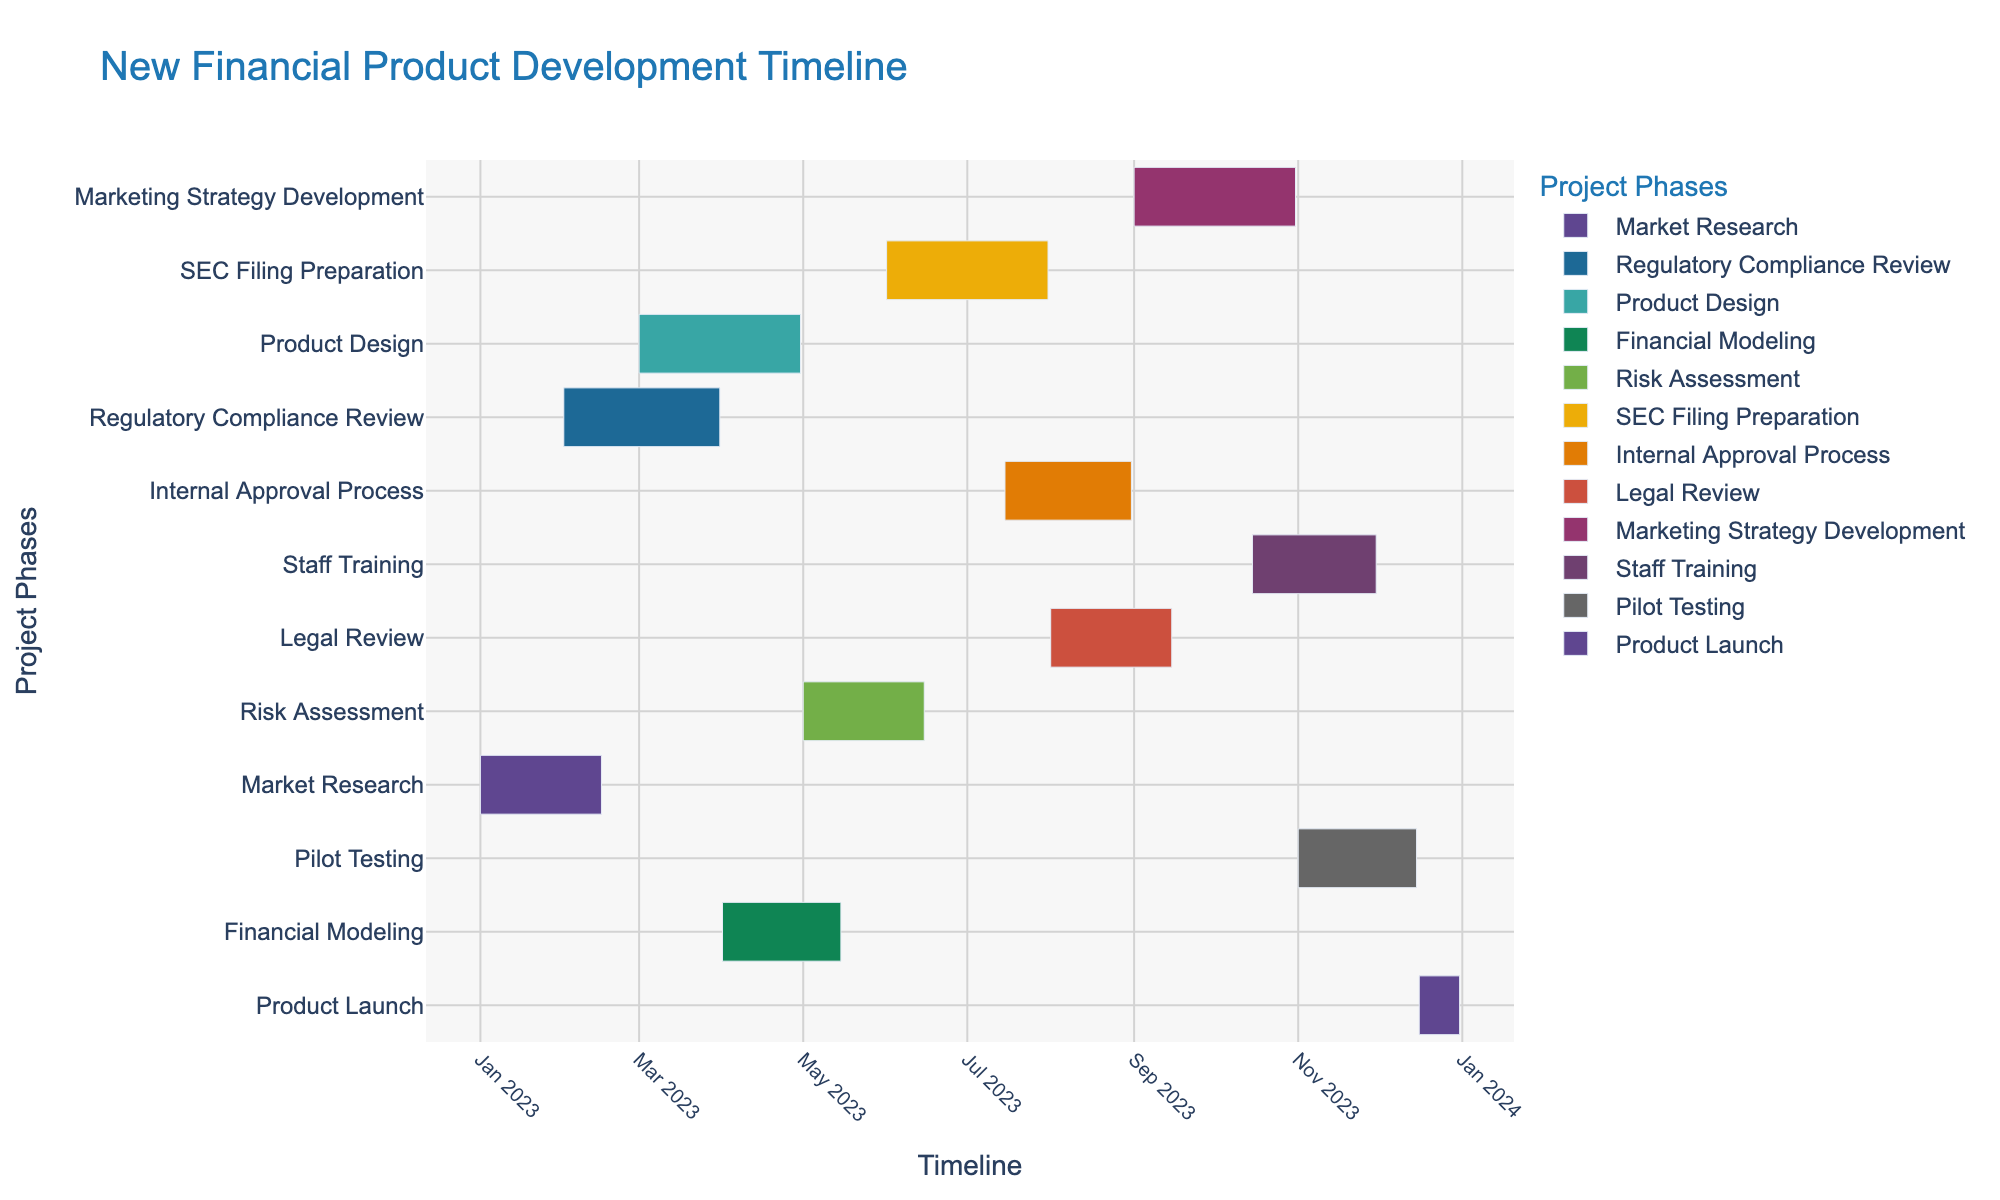What is the total duration of the "Market Research" phase? The "Market Research" phase starts on January 1, 2023, and ends on February 15, 2023. Calculating the duration between these two dates: Duration = February 15, 2023 - January 1, 2023 = 45 days
Answer: 45 days Which project phase overlaps with both "Market Research" and "Product Design"? To determine which phase overlaps with both "Market Research" and "Product Design," we look for a project phase that starts before "Market Research" ends (February 15, 2023) and ends after "Product Design" starts (March 1, 2023). "Regulatory Compliance Review" fits this as it starts on February 1, 2023, and ends on March 31, 2023
Answer: Regulatory Compliance Review When does the "Pilot Testing" phase commence and conclude? The "Pilot Testing" phase begins on November 1, 2023, and ends on December 15, 2023, based on the Gantt chart's provided timeline.
Answer: November 1, 2023, to December 15, 2023 What activities are ongoing in July 2023? To find the activities ongoing in July 2023, examine the phases that overlap with the timeline of July 2023. The phases are "SEC Filing Preparation," "Internal Approval Process," and "Legal Review."
Answer: SEC Filing Preparation, Internal Approval Process, Legal Review What is the shortest project phase in terms of duration? To determine the shortest project phase, compare the durations of each phase. The shortest phase is the "Product Launch" phase, which has a duration of 15 days (December 16, 2023, to December 31, 2023).
Answer: Product Launch How many phases are overlapping with "Staff Training"? "Staff Training" runs from October 15, 2023, to November 30, 2023. Evaluating the timeline on this chart shows that "Marketing Strategy Development" and "Pilot Testing" overlap with "Staff Training."
Answer: Two phases What phase follows immediately after "Internal Approval Process"? The sequence of phases on the Gantt chart shows that "Legal Review" begins immediately after "Internal Approval Process" ends on August 31, 2023, with "Legal Review" starting on September 1, 2023.
Answer: Legal Review How many days will take from the start of "Financial Modeling" to the end of the "Pilot Testing"? "Financial Modeling" starts on April 1, 2023, and "Pilot Testing" ends on December 15, 2023. Calculating the duration: December 15, 2023 - April 1, 2023 = 258 days.
Answer: 258 days What are the starting and ending dates for "Marketing Strategy Development"? Based on the chart, "Marketing Strategy Development" starts on September 1, 2023, and ends on October 31, 2023.
Answer: September 1, 2023, to October 31, 2023 